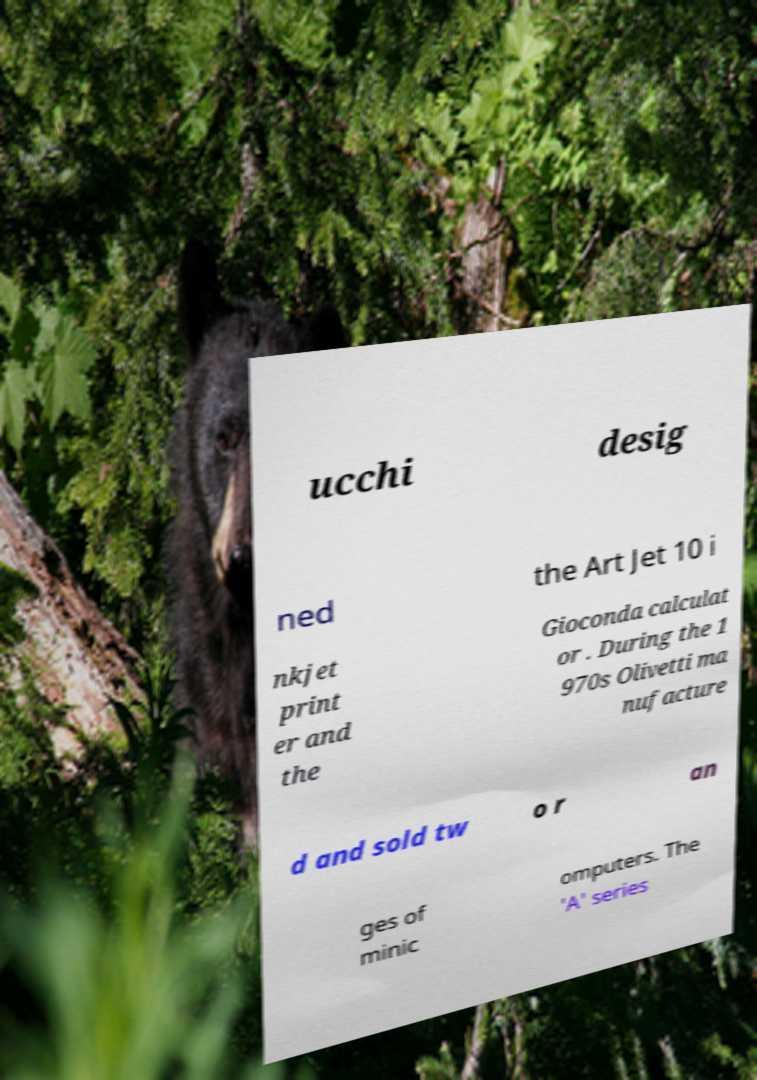I need the written content from this picture converted into text. Can you do that? ucchi desig ned the Art Jet 10 i nkjet print er and the Gioconda calculat or . During the 1 970s Olivetti ma nufacture d and sold tw o r an ges of minic omputers. The 'A' series 